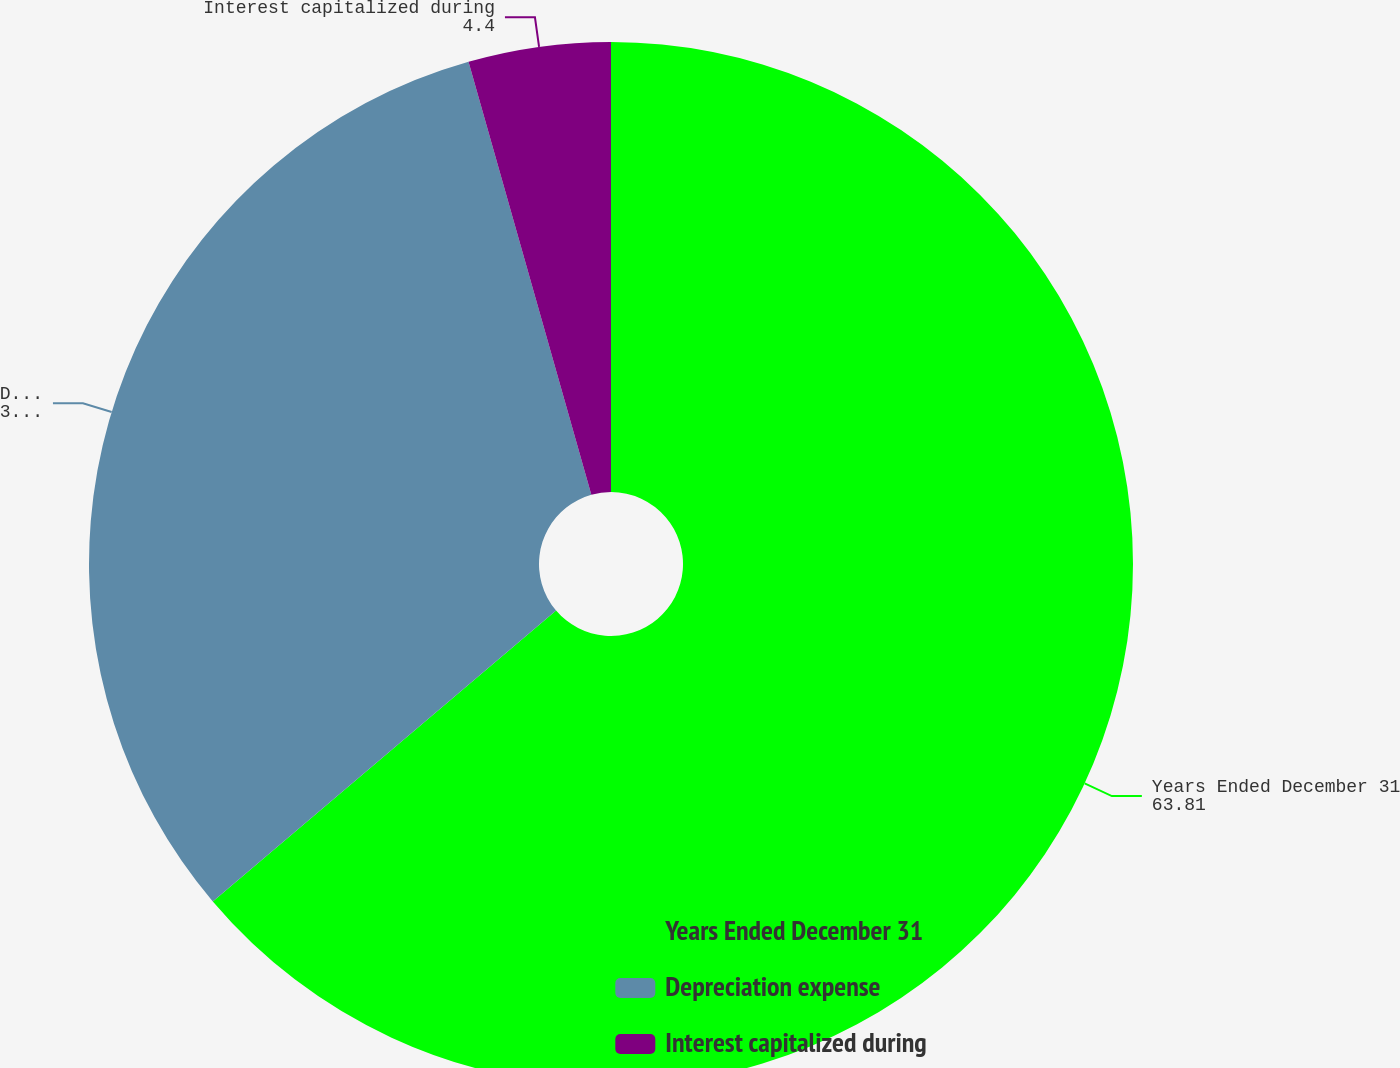Convert chart to OTSL. <chart><loc_0><loc_0><loc_500><loc_500><pie_chart><fcel>Years Ended December 31<fcel>Depreciation expense<fcel>Interest capitalized during<nl><fcel>63.81%<fcel>31.79%<fcel>4.4%<nl></chart> 